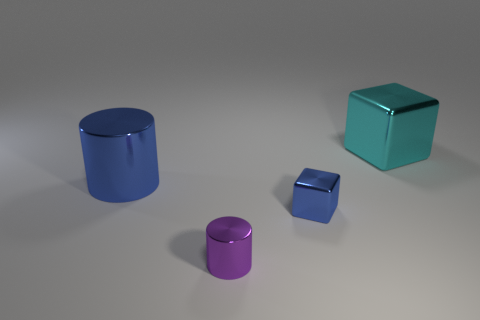Subtract all blue cylinders. How many cylinders are left? 1 Subtract 2 cylinders. How many cylinders are left? 0 Add 2 big red cubes. How many objects exist? 6 Add 2 large cylinders. How many large cylinders are left? 3 Add 1 small blue metal objects. How many small blue metal objects exist? 2 Subtract 0 yellow balls. How many objects are left? 4 Subtract all purple cubes. Subtract all brown cylinders. How many cubes are left? 2 Subtract all big blue shiny cylinders. Subtract all gray metallic cylinders. How many objects are left? 3 